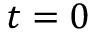Convert formula to latex. <formula><loc_0><loc_0><loc_500><loc_500>t = 0</formula> 